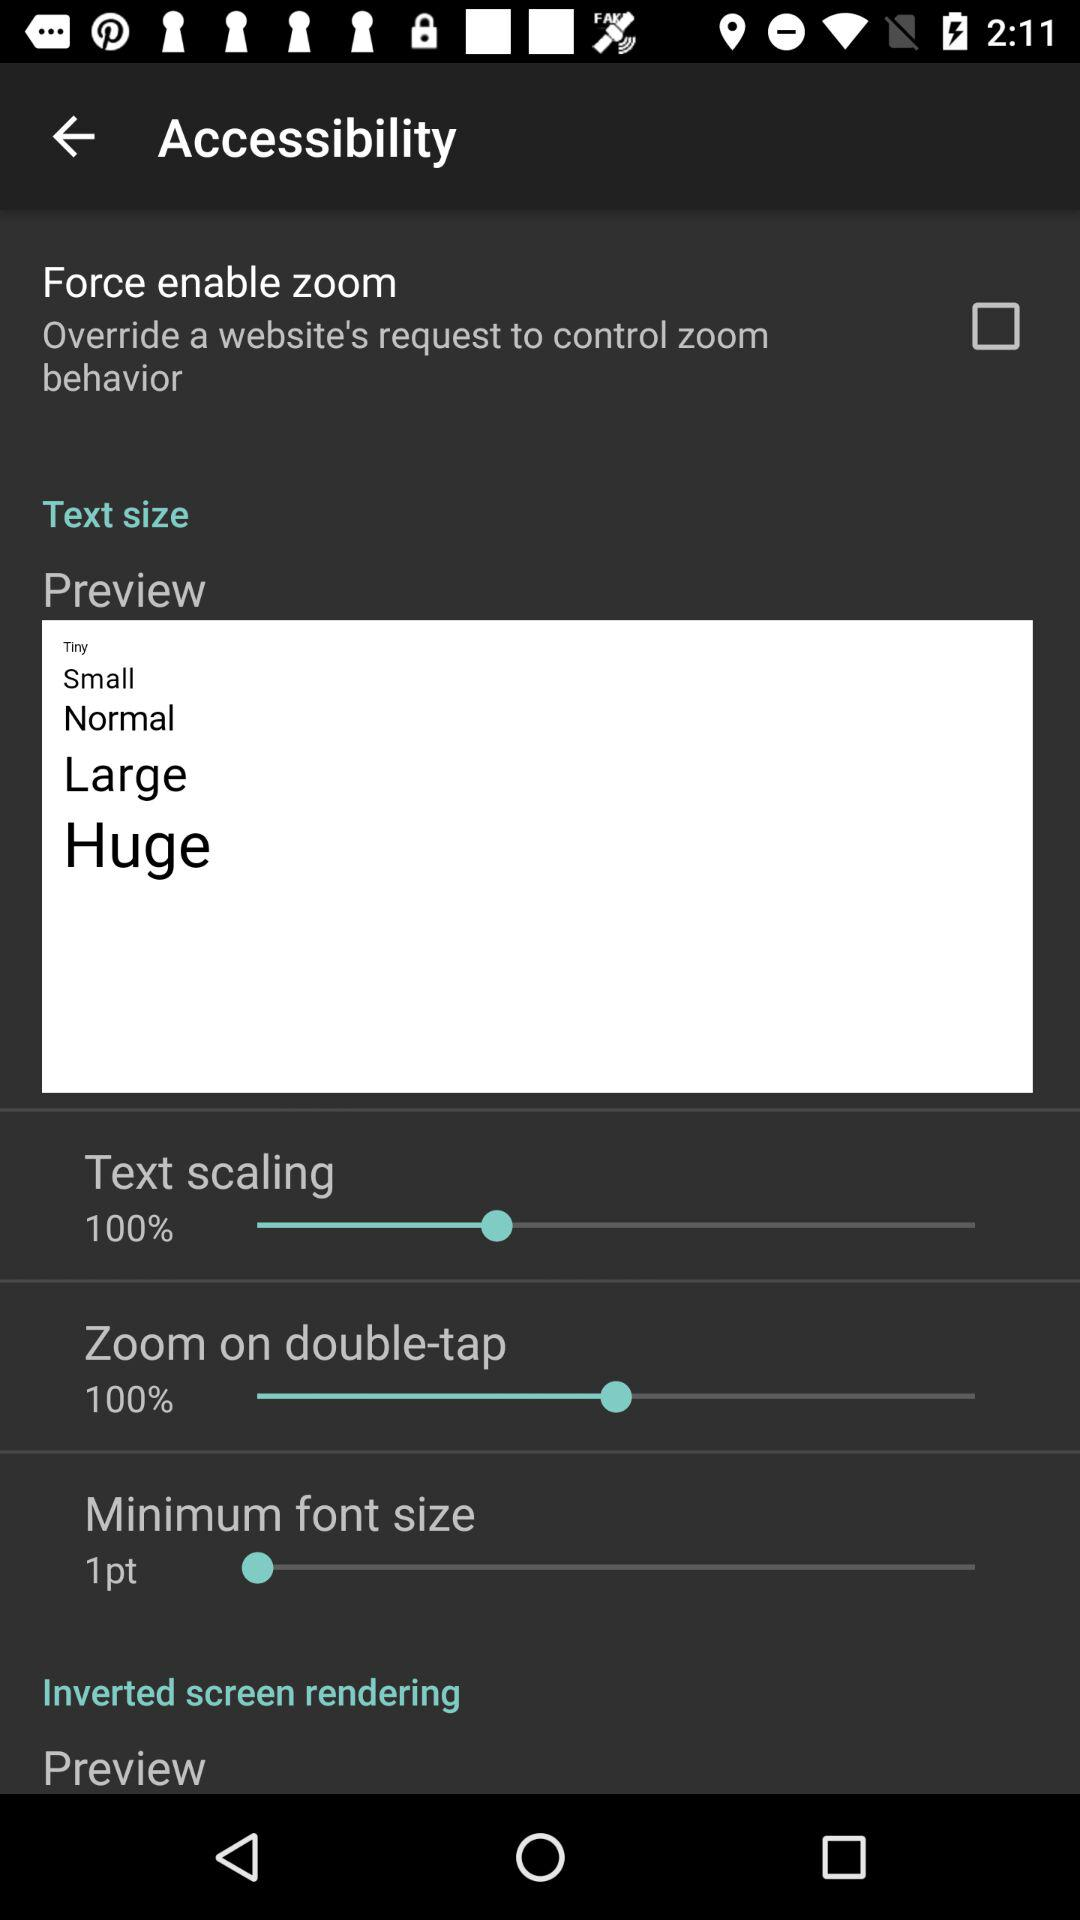What is the selected percentage for text scaling? The selected percentage is 100. 